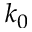Convert formula to latex. <formula><loc_0><loc_0><loc_500><loc_500>k _ { 0 }</formula> 